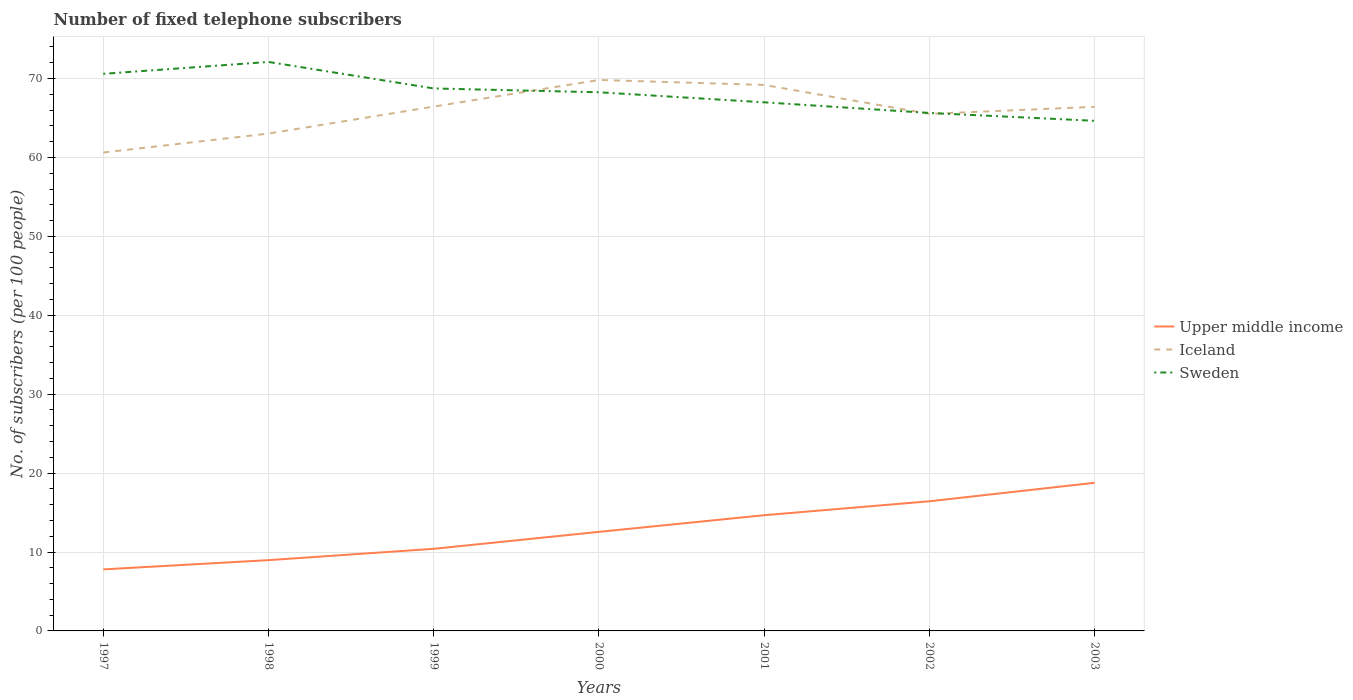Is the number of lines equal to the number of legend labels?
Offer a very short reply. Yes. Across all years, what is the maximum number of fixed telephone subscribers in Sweden?
Offer a terse response. 64.64. What is the total number of fixed telephone subscribers in Upper middle income in the graph?
Offer a terse response. -6.02. What is the difference between the highest and the second highest number of fixed telephone subscribers in Upper middle income?
Offer a terse response. 10.98. What is the difference between the highest and the lowest number of fixed telephone subscribers in Iceland?
Make the answer very short. 4. How many lines are there?
Provide a succinct answer. 3. Are the values on the major ticks of Y-axis written in scientific E-notation?
Ensure brevity in your answer.  No. Does the graph contain any zero values?
Offer a very short reply. No. Does the graph contain grids?
Make the answer very short. Yes. Where does the legend appear in the graph?
Offer a very short reply. Center right. How many legend labels are there?
Give a very brief answer. 3. What is the title of the graph?
Your answer should be compact. Number of fixed telephone subscribers. What is the label or title of the Y-axis?
Make the answer very short. No. of subscribers (per 100 people). What is the No. of subscribers (per 100 people) in Upper middle income in 1997?
Provide a short and direct response. 7.8. What is the No. of subscribers (per 100 people) of Iceland in 1997?
Offer a terse response. 60.63. What is the No. of subscribers (per 100 people) in Sweden in 1997?
Make the answer very short. 70.59. What is the No. of subscribers (per 100 people) of Upper middle income in 1998?
Provide a succinct answer. 8.97. What is the No. of subscribers (per 100 people) in Iceland in 1998?
Provide a short and direct response. 63.02. What is the No. of subscribers (per 100 people) in Sweden in 1998?
Offer a terse response. 72.1. What is the No. of subscribers (per 100 people) in Upper middle income in 1999?
Ensure brevity in your answer.  10.41. What is the No. of subscribers (per 100 people) of Iceland in 1999?
Keep it short and to the point. 66.45. What is the No. of subscribers (per 100 people) in Sweden in 1999?
Provide a short and direct response. 68.74. What is the No. of subscribers (per 100 people) of Upper middle income in 2000?
Give a very brief answer. 12.55. What is the No. of subscribers (per 100 people) in Iceland in 2000?
Your response must be concise. 69.82. What is the No. of subscribers (per 100 people) in Sweden in 2000?
Ensure brevity in your answer.  68.26. What is the No. of subscribers (per 100 people) of Upper middle income in 2001?
Your response must be concise. 14.66. What is the No. of subscribers (per 100 people) of Iceland in 2001?
Your answer should be compact. 69.19. What is the No. of subscribers (per 100 people) in Sweden in 2001?
Offer a very short reply. 66.99. What is the No. of subscribers (per 100 people) of Upper middle income in 2002?
Your answer should be compact. 16.43. What is the No. of subscribers (per 100 people) in Iceland in 2002?
Provide a short and direct response. 65.52. What is the No. of subscribers (per 100 people) in Sweden in 2002?
Ensure brevity in your answer.  65.64. What is the No. of subscribers (per 100 people) of Upper middle income in 2003?
Keep it short and to the point. 18.77. What is the No. of subscribers (per 100 people) in Iceland in 2003?
Your response must be concise. 66.41. What is the No. of subscribers (per 100 people) in Sweden in 2003?
Your answer should be compact. 64.64. Across all years, what is the maximum No. of subscribers (per 100 people) of Upper middle income?
Provide a short and direct response. 18.77. Across all years, what is the maximum No. of subscribers (per 100 people) in Iceland?
Provide a succinct answer. 69.82. Across all years, what is the maximum No. of subscribers (per 100 people) in Sweden?
Ensure brevity in your answer.  72.1. Across all years, what is the minimum No. of subscribers (per 100 people) of Upper middle income?
Offer a very short reply. 7.8. Across all years, what is the minimum No. of subscribers (per 100 people) in Iceland?
Provide a short and direct response. 60.63. Across all years, what is the minimum No. of subscribers (per 100 people) in Sweden?
Your response must be concise. 64.64. What is the total No. of subscribers (per 100 people) in Upper middle income in the graph?
Your response must be concise. 89.59. What is the total No. of subscribers (per 100 people) of Iceland in the graph?
Give a very brief answer. 461.04. What is the total No. of subscribers (per 100 people) in Sweden in the graph?
Make the answer very short. 476.96. What is the difference between the No. of subscribers (per 100 people) of Upper middle income in 1997 and that in 1998?
Offer a very short reply. -1.17. What is the difference between the No. of subscribers (per 100 people) of Iceland in 1997 and that in 1998?
Provide a short and direct response. -2.4. What is the difference between the No. of subscribers (per 100 people) of Sweden in 1997 and that in 1998?
Provide a short and direct response. -1.51. What is the difference between the No. of subscribers (per 100 people) of Upper middle income in 1997 and that in 1999?
Provide a succinct answer. -2.61. What is the difference between the No. of subscribers (per 100 people) in Iceland in 1997 and that in 1999?
Your answer should be very brief. -5.82. What is the difference between the No. of subscribers (per 100 people) in Sweden in 1997 and that in 1999?
Offer a very short reply. 1.85. What is the difference between the No. of subscribers (per 100 people) in Upper middle income in 1997 and that in 2000?
Offer a terse response. -4.76. What is the difference between the No. of subscribers (per 100 people) in Iceland in 1997 and that in 2000?
Give a very brief answer. -9.19. What is the difference between the No. of subscribers (per 100 people) of Sweden in 1997 and that in 2000?
Provide a short and direct response. 2.34. What is the difference between the No. of subscribers (per 100 people) in Upper middle income in 1997 and that in 2001?
Your response must be concise. -6.87. What is the difference between the No. of subscribers (per 100 people) in Iceland in 1997 and that in 2001?
Your response must be concise. -8.56. What is the difference between the No. of subscribers (per 100 people) of Sweden in 1997 and that in 2001?
Your answer should be very brief. 3.61. What is the difference between the No. of subscribers (per 100 people) in Upper middle income in 1997 and that in 2002?
Offer a terse response. -8.63. What is the difference between the No. of subscribers (per 100 people) in Iceland in 1997 and that in 2002?
Ensure brevity in your answer.  -4.89. What is the difference between the No. of subscribers (per 100 people) of Sweden in 1997 and that in 2002?
Provide a succinct answer. 4.96. What is the difference between the No. of subscribers (per 100 people) of Upper middle income in 1997 and that in 2003?
Provide a short and direct response. -10.98. What is the difference between the No. of subscribers (per 100 people) in Iceland in 1997 and that in 2003?
Provide a succinct answer. -5.79. What is the difference between the No. of subscribers (per 100 people) of Sweden in 1997 and that in 2003?
Give a very brief answer. 5.95. What is the difference between the No. of subscribers (per 100 people) of Upper middle income in 1998 and that in 1999?
Offer a very short reply. -1.44. What is the difference between the No. of subscribers (per 100 people) of Iceland in 1998 and that in 1999?
Your response must be concise. -3.42. What is the difference between the No. of subscribers (per 100 people) of Sweden in 1998 and that in 1999?
Your response must be concise. 3.36. What is the difference between the No. of subscribers (per 100 people) of Upper middle income in 1998 and that in 2000?
Your answer should be very brief. -3.58. What is the difference between the No. of subscribers (per 100 people) of Iceland in 1998 and that in 2000?
Your response must be concise. -6.79. What is the difference between the No. of subscribers (per 100 people) in Sweden in 1998 and that in 2000?
Offer a very short reply. 3.84. What is the difference between the No. of subscribers (per 100 people) of Upper middle income in 1998 and that in 2001?
Give a very brief answer. -5.69. What is the difference between the No. of subscribers (per 100 people) in Iceland in 1998 and that in 2001?
Provide a succinct answer. -6.16. What is the difference between the No. of subscribers (per 100 people) of Sweden in 1998 and that in 2001?
Offer a terse response. 5.12. What is the difference between the No. of subscribers (per 100 people) in Upper middle income in 1998 and that in 2002?
Provide a short and direct response. -7.46. What is the difference between the No. of subscribers (per 100 people) in Iceland in 1998 and that in 2002?
Your response must be concise. -2.5. What is the difference between the No. of subscribers (per 100 people) of Sweden in 1998 and that in 2002?
Your response must be concise. 6.46. What is the difference between the No. of subscribers (per 100 people) of Upper middle income in 1998 and that in 2003?
Offer a very short reply. -9.8. What is the difference between the No. of subscribers (per 100 people) in Iceland in 1998 and that in 2003?
Give a very brief answer. -3.39. What is the difference between the No. of subscribers (per 100 people) of Sweden in 1998 and that in 2003?
Your response must be concise. 7.46. What is the difference between the No. of subscribers (per 100 people) in Upper middle income in 1999 and that in 2000?
Keep it short and to the point. -2.15. What is the difference between the No. of subscribers (per 100 people) in Iceland in 1999 and that in 2000?
Offer a terse response. -3.37. What is the difference between the No. of subscribers (per 100 people) in Sweden in 1999 and that in 2000?
Offer a very short reply. 0.48. What is the difference between the No. of subscribers (per 100 people) of Upper middle income in 1999 and that in 2001?
Keep it short and to the point. -4.26. What is the difference between the No. of subscribers (per 100 people) in Iceland in 1999 and that in 2001?
Ensure brevity in your answer.  -2.74. What is the difference between the No. of subscribers (per 100 people) in Sweden in 1999 and that in 2001?
Your answer should be compact. 1.76. What is the difference between the No. of subscribers (per 100 people) in Upper middle income in 1999 and that in 2002?
Offer a terse response. -6.02. What is the difference between the No. of subscribers (per 100 people) in Iceland in 1999 and that in 2002?
Ensure brevity in your answer.  0.93. What is the difference between the No. of subscribers (per 100 people) of Sweden in 1999 and that in 2002?
Provide a succinct answer. 3.1. What is the difference between the No. of subscribers (per 100 people) in Upper middle income in 1999 and that in 2003?
Offer a very short reply. -8.37. What is the difference between the No. of subscribers (per 100 people) in Iceland in 1999 and that in 2003?
Your answer should be compact. 0.03. What is the difference between the No. of subscribers (per 100 people) in Sweden in 1999 and that in 2003?
Your answer should be very brief. 4.1. What is the difference between the No. of subscribers (per 100 people) of Upper middle income in 2000 and that in 2001?
Make the answer very short. -2.11. What is the difference between the No. of subscribers (per 100 people) of Iceland in 2000 and that in 2001?
Ensure brevity in your answer.  0.63. What is the difference between the No. of subscribers (per 100 people) in Sweden in 2000 and that in 2001?
Provide a succinct answer. 1.27. What is the difference between the No. of subscribers (per 100 people) in Upper middle income in 2000 and that in 2002?
Ensure brevity in your answer.  -3.88. What is the difference between the No. of subscribers (per 100 people) of Iceland in 2000 and that in 2002?
Provide a short and direct response. 4.3. What is the difference between the No. of subscribers (per 100 people) of Sweden in 2000 and that in 2002?
Keep it short and to the point. 2.62. What is the difference between the No. of subscribers (per 100 people) in Upper middle income in 2000 and that in 2003?
Make the answer very short. -6.22. What is the difference between the No. of subscribers (per 100 people) of Iceland in 2000 and that in 2003?
Keep it short and to the point. 3.4. What is the difference between the No. of subscribers (per 100 people) of Sweden in 2000 and that in 2003?
Your answer should be compact. 3.62. What is the difference between the No. of subscribers (per 100 people) in Upper middle income in 2001 and that in 2002?
Ensure brevity in your answer.  -1.77. What is the difference between the No. of subscribers (per 100 people) in Iceland in 2001 and that in 2002?
Offer a very short reply. 3.67. What is the difference between the No. of subscribers (per 100 people) of Sweden in 2001 and that in 2002?
Keep it short and to the point. 1.35. What is the difference between the No. of subscribers (per 100 people) of Upper middle income in 2001 and that in 2003?
Keep it short and to the point. -4.11. What is the difference between the No. of subscribers (per 100 people) in Iceland in 2001 and that in 2003?
Give a very brief answer. 2.77. What is the difference between the No. of subscribers (per 100 people) in Sweden in 2001 and that in 2003?
Offer a very short reply. 2.35. What is the difference between the No. of subscribers (per 100 people) of Upper middle income in 2002 and that in 2003?
Give a very brief answer. -2.34. What is the difference between the No. of subscribers (per 100 people) of Iceland in 2002 and that in 2003?
Your answer should be compact. -0.89. What is the difference between the No. of subscribers (per 100 people) in Sweden in 2002 and that in 2003?
Give a very brief answer. 1. What is the difference between the No. of subscribers (per 100 people) of Upper middle income in 1997 and the No. of subscribers (per 100 people) of Iceland in 1998?
Ensure brevity in your answer.  -55.23. What is the difference between the No. of subscribers (per 100 people) in Upper middle income in 1997 and the No. of subscribers (per 100 people) in Sweden in 1998?
Keep it short and to the point. -64.3. What is the difference between the No. of subscribers (per 100 people) in Iceland in 1997 and the No. of subscribers (per 100 people) in Sweden in 1998?
Offer a very short reply. -11.47. What is the difference between the No. of subscribers (per 100 people) of Upper middle income in 1997 and the No. of subscribers (per 100 people) of Iceland in 1999?
Keep it short and to the point. -58.65. What is the difference between the No. of subscribers (per 100 people) in Upper middle income in 1997 and the No. of subscribers (per 100 people) in Sweden in 1999?
Your response must be concise. -60.94. What is the difference between the No. of subscribers (per 100 people) of Iceland in 1997 and the No. of subscribers (per 100 people) of Sweden in 1999?
Make the answer very short. -8.11. What is the difference between the No. of subscribers (per 100 people) of Upper middle income in 1997 and the No. of subscribers (per 100 people) of Iceland in 2000?
Your answer should be very brief. -62.02. What is the difference between the No. of subscribers (per 100 people) of Upper middle income in 1997 and the No. of subscribers (per 100 people) of Sweden in 2000?
Ensure brevity in your answer.  -60.46. What is the difference between the No. of subscribers (per 100 people) of Iceland in 1997 and the No. of subscribers (per 100 people) of Sweden in 2000?
Ensure brevity in your answer.  -7.63. What is the difference between the No. of subscribers (per 100 people) in Upper middle income in 1997 and the No. of subscribers (per 100 people) in Iceland in 2001?
Provide a succinct answer. -61.39. What is the difference between the No. of subscribers (per 100 people) of Upper middle income in 1997 and the No. of subscribers (per 100 people) of Sweden in 2001?
Ensure brevity in your answer.  -59.19. What is the difference between the No. of subscribers (per 100 people) of Iceland in 1997 and the No. of subscribers (per 100 people) of Sweden in 2001?
Your answer should be compact. -6.36. What is the difference between the No. of subscribers (per 100 people) of Upper middle income in 1997 and the No. of subscribers (per 100 people) of Iceland in 2002?
Offer a terse response. -57.72. What is the difference between the No. of subscribers (per 100 people) in Upper middle income in 1997 and the No. of subscribers (per 100 people) in Sweden in 2002?
Offer a very short reply. -57.84. What is the difference between the No. of subscribers (per 100 people) of Iceland in 1997 and the No. of subscribers (per 100 people) of Sweden in 2002?
Offer a terse response. -5.01. What is the difference between the No. of subscribers (per 100 people) in Upper middle income in 1997 and the No. of subscribers (per 100 people) in Iceland in 2003?
Make the answer very short. -58.62. What is the difference between the No. of subscribers (per 100 people) in Upper middle income in 1997 and the No. of subscribers (per 100 people) in Sweden in 2003?
Your answer should be very brief. -56.84. What is the difference between the No. of subscribers (per 100 people) of Iceland in 1997 and the No. of subscribers (per 100 people) of Sweden in 2003?
Make the answer very short. -4.01. What is the difference between the No. of subscribers (per 100 people) of Upper middle income in 1998 and the No. of subscribers (per 100 people) of Iceland in 1999?
Your answer should be compact. -57.48. What is the difference between the No. of subscribers (per 100 people) of Upper middle income in 1998 and the No. of subscribers (per 100 people) of Sweden in 1999?
Give a very brief answer. -59.77. What is the difference between the No. of subscribers (per 100 people) of Iceland in 1998 and the No. of subscribers (per 100 people) of Sweden in 1999?
Offer a very short reply. -5.72. What is the difference between the No. of subscribers (per 100 people) in Upper middle income in 1998 and the No. of subscribers (per 100 people) in Iceland in 2000?
Ensure brevity in your answer.  -60.85. What is the difference between the No. of subscribers (per 100 people) in Upper middle income in 1998 and the No. of subscribers (per 100 people) in Sweden in 2000?
Ensure brevity in your answer.  -59.29. What is the difference between the No. of subscribers (per 100 people) in Iceland in 1998 and the No. of subscribers (per 100 people) in Sweden in 2000?
Provide a short and direct response. -5.23. What is the difference between the No. of subscribers (per 100 people) of Upper middle income in 1998 and the No. of subscribers (per 100 people) of Iceland in 2001?
Your answer should be compact. -60.22. What is the difference between the No. of subscribers (per 100 people) of Upper middle income in 1998 and the No. of subscribers (per 100 people) of Sweden in 2001?
Keep it short and to the point. -58.02. What is the difference between the No. of subscribers (per 100 people) in Iceland in 1998 and the No. of subscribers (per 100 people) in Sweden in 2001?
Your answer should be very brief. -3.96. What is the difference between the No. of subscribers (per 100 people) in Upper middle income in 1998 and the No. of subscribers (per 100 people) in Iceland in 2002?
Provide a succinct answer. -56.55. What is the difference between the No. of subscribers (per 100 people) in Upper middle income in 1998 and the No. of subscribers (per 100 people) in Sweden in 2002?
Offer a very short reply. -56.67. What is the difference between the No. of subscribers (per 100 people) in Iceland in 1998 and the No. of subscribers (per 100 people) in Sweden in 2002?
Ensure brevity in your answer.  -2.61. What is the difference between the No. of subscribers (per 100 people) in Upper middle income in 1998 and the No. of subscribers (per 100 people) in Iceland in 2003?
Give a very brief answer. -57.44. What is the difference between the No. of subscribers (per 100 people) of Upper middle income in 1998 and the No. of subscribers (per 100 people) of Sweden in 2003?
Keep it short and to the point. -55.67. What is the difference between the No. of subscribers (per 100 people) of Iceland in 1998 and the No. of subscribers (per 100 people) of Sweden in 2003?
Provide a short and direct response. -1.62. What is the difference between the No. of subscribers (per 100 people) of Upper middle income in 1999 and the No. of subscribers (per 100 people) of Iceland in 2000?
Your response must be concise. -59.41. What is the difference between the No. of subscribers (per 100 people) in Upper middle income in 1999 and the No. of subscribers (per 100 people) in Sweden in 2000?
Offer a very short reply. -57.85. What is the difference between the No. of subscribers (per 100 people) of Iceland in 1999 and the No. of subscribers (per 100 people) of Sweden in 2000?
Your answer should be very brief. -1.81. What is the difference between the No. of subscribers (per 100 people) in Upper middle income in 1999 and the No. of subscribers (per 100 people) in Iceland in 2001?
Your answer should be compact. -58.78. What is the difference between the No. of subscribers (per 100 people) in Upper middle income in 1999 and the No. of subscribers (per 100 people) in Sweden in 2001?
Ensure brevity in your answer.  -56.58. What is the difference between the No. of subscribers (per 100 people) in Iceland in 1999 and the No. of subscribers (per 100 people) in Sweden in 2001?
Make the answer very short. -0.54. What is the difference between the No. of subscribers (per 100 people) in Upper middle income in 1999 and the No. of subscribers (per 100 people) in Iceland in 2002?
Offer a terse response. -55.12. What is the difference between the No. of subscribers (per 100 people) in Upper middle income in 1999 and the No. of subscribers (per 100 people) in Sweden in 2002?
Make the answer very short. -55.23. What is the difference between the No. of subscribers (per 100 people) of Iceland in 1999 and the No. of subscribers (per 100 people) of Sweden in 2002?
Provide a short and direct response. 0.81. What is the difference between the No. of subscribers (per 100 people) in Upper middle income in 1999 and the No. of subscribers (per 100 people) in Iceland in 2003?
Offer a very short reply. -56.01. What is the difference between the No. of subscribers (per 100 people) in Upper middle income in 1999 and the No. of subscribers (per 100 people) in Sweden in 2003?
Your response must be concise. -54.24. What is the difference between the No. of subscribers (per 100 people) in Iceland in 1999 and the No. of subscribers (per 100 people) in Sweden in 2003?
Give a very brief answer. 1.81. What is the difference between the No. of subscribers (per 100 people) in Upper middle income in 2000 and the No. of subscribers (per 100 people) in Iceland in 2001?
Make the answer very short. -56.63. What is the difference between the No. of subscribers (per 100 people) of Upper middle income in 2000 and the No. of subscribers (per 100 people) of Sweden in 2001?
Make the answer very short. -54.43. What is the difference between the No. of subscribers (per 100 people) in Iceland in 2000 and the No. of subscribers (per 100 people) in Sweden in 2001?
Make the answer very short. 2.83. What is the difference between the No. of subscribers (per 100 people) of Upper middle income in 2000 and the No. of subscribers (per 100 people) of Iceland in 2002?
Your response must be concise. -52.97. What is the difference between the No. of subscribers (per 100 people) in Upper middle income in 2000 and the No. of subscribers (per 100 people) in Sweden in 2002?
Your answer should be very brief. -53.08. What is the difference between the No. of subscribers (per 100 people) in Iceland in 2000 and the No. of subscribers (per 100 people) in Sweden in 2002?
Offer a terse response. 4.18. What is the difference between the No. of subscribers (per 100 people) of Upper middle income in 2000 and the No. of subscribers (per 100 people) of Iceland in 2003?
Offer a very short reply. -53.86. What is the difference between the No. of subscribers (per 100 people) of Upper middle income in 2000 and the No. of subscribers (per 100 people) of Sweden in 2003?
Offer a very short reply. -52.09. What is the difference between the No. of subscribers (per 100 people) of Iceland in 2000 and the No. of subscribers (per 100 people) of Sweden in 2003?
Make the answer very short. 5.18. What is the difference between the No. of subscribers (per 100 people) in Upper middle income in 2001 and the No. of subscribers (per 100 people) in Iceland in 2002?
Give a very brief answer. -50.86. What is the difference between the No. of subscribers (per 100 people) in Upper middle income in 2001 and the No. of subscribers (per 100 people) in Sweden in 2002?
Keep it short and to the point. -50.97. What is the difference between the No. of subscribers (per 100 people) in Iceland in 2001 and the No. of subscribers (per 100 people) in Sweden in 2002?
Make the answer very short. 3.55. What is the difference between the No. of subscribers (per 100 people) in Upper middle income in 2001 and the No. of subscribers (per 100 people) in Iceland in 2003?
Your response must be concise. -51.75. What is the difference between the No. of subscribers (per 100 people) in Upper middle income in 2001 and the No. of subscribers (per 100 people) in Sweden in 2003?
Keep it short and to the point. -49.98. What is the difference between the No. of subscribers (per 100 people) in Iceland in 2001 and the No. of subscribers (per 100 people) in Sweden in 2003?
Provide a succinct answer. 4.55. What is the difference between the No. of subscribers (per 100 people) of Upper middle income in 2002 and the No. of subscribers (per 100 people) of Iceland in 2003?
Provide a short and direct response. -49.98. What is the difference between the No. of subscribers (per 100 people) of Upper middle income in 2002 and the No. of subscribers (per 100 people) of Sweden in 2003?
Ensure brevity in your answer.  -48.21. What is the difference between the No. of subscribers (per 100 people) in Iceland in 2002 and the No. of subscribers (per 100 people) in Sweden in 2003?
Provide a short and direct response. 0.88. What is the average No. of subscribers (per 100 people) of Upper middle income per year?
Your answer should be very brief. 12.8. What is the average No. of subscribers (per 100 people) of Iceland per year?
Your answer should be compact. 65.86. What is the average No. of subscribers (per 100 people) in Sweden per year?
Offer a very short reply. 68.14. In the year 1997, what is the difference between the No. of subscribers (per 100 people) of Upper middle income and No. of subscribers (per 100 people) of Iceland?
Make the answer very short. -52.83. In the year 1997, what is the difference between the No. of subscribers (per 100 people) in Upper middle income and No. of subscribers (per 100 people) in Sweden?
Keep it short and to the point. -62.8. In the year 1997, what is the difference between the No. of subscribers (per 100 people) in Iceland and No. of subscribers (per 100 people) in Sweden?
Provide a succinct answer. -9.97. In the year 1998, what is the difference between the No. of subscribers (per 100 people) of Upper middle income and No. of subscribers (per 100 people) of Iceland?
Provide a succinct answer. -54.05. In the year 1998, what is the difference between the No. of subscribers (per 100 people) of Upper middle income and No. of subscribers (per 100 people) of Sweden?
Offer a very short reply. -63.13. In the year 1998, what is the difference between the No. of subscribers (per 100 people) of Iceland and No. of subscribers (per 100 people) of Sweden?
Give a very brief answer. -9.08. In the year 1999, what is the difference between the No. of subscribers (per 100 people) in Upper middle income and No. of subscribers (per 100 people) in Iceland?
Your answer should be compact. -56.04. In the year 1999, what is the difference between the No. of subscribers (per 100 people) of Upper middle income and No. of subscribers (per 100 people) of Sweden?
Your answer should be compact. -58.34. In the year 1999, what is the difference between the No. of subscribers (per 100 people) in Iceland and No. of subscribers (per 100 people) in Sweden?
Make the answer very short. -2.29. In the year 2000, what is the difference between the No. of subscribers (per 100 people) of Upper middle income and No. of subscribers (per 100 people) of Iceland?
Offer a terse response. -57.26. In the year 2000, what is the difference between the No. of subscribers (per 100 people) in Upper middle income and No. of subscribers (per 100 people) in Sweden?
Provide a succinct answer. -55.7. In the year 2000, what is the difference between the No. of subscribers (per 100 people) in Iceland and No. of subscribers (per 100 people) in Sweden?
Give a very brief answer. 1.56. In the year 2001, what is the difference between the No. of subscribers (per 100 people) in Upper middle income and No. of subscribers (per 100 people) in Iceland?
Ensure brevity in your answer.  -54.52. In the year 2001, what is the difference between the No. of subscribers (per 100 people) in Upper middle income and No. of subscribers (per 100 people) in Sweden?
Your answer should be very brief. -52.32. In the year 2001, what is the difference between the No. of subscribers (per 100 people) of Iceland and No. of subscribers (per 100 people) of Sweden?
Provide a short and direct response. 2.2. In the year 2002, what is the difference between the No. of subscribers (per 100 people) of Upper middle income and No. of subscribers (per 100 people) of Iceland?
Offer a very short reply. -49.09. In the year 2002, what is the difference between the No. of subscribers (per 100 people) of Upper middle income and No. of subscribers (per 100 people) of Sweden?
Your answer should be compact. -49.21. In the year 2002, what is the difference between the No. of subscribers (per 100 people) in Iceland and No. of subscribers (per 100 people) in Sweden?
Offer a terse response. -0.12. In the year 2003, what is the difference between the No. of subscribers (per 100 people) in Upper middle income and No. of subscribers (per 100 people) in Iceland?
Offer a very short reply. -47.64. In the year 2003, what is the difference between the No. of subscribers (per 100 people) of Upper middle income and No. of subscribers (per 100 people) of Sweden?
Ensure brevity in your answer.  -45.87. In the year 2003, what is the difference between the No. of subscribers (per 100 people) in Iceland and No. of subscribers (per 100 people) in Sweden?
Provide a succinct answer. 1.77. What is the ratio of the No. of subscribers (per 100 people) of Upper middle income in 1997 to that in 1998?
Your answer should be compact. 0.87. What is the ratio of the No. of subscribers (per 100 people) of Iceland in 1997 to that in 1998?
Give a very brief answer. 0.96. What is the ratio of the No. of subscribers (per 100 people) in Sweden in 1997 to that in 1998?
Your answer should be very brief. 0.98. What is the ratio of the No. of subscribers (per 100 people) of Upper middle income in 1997 to that in 1999?
Provide a succinct answer. 0.75. What is the ratio of the No. of subscribers (per 100 people) of Iceland in 1997 to that in 1999?
Your answer should be very brief. 0.91. What is the ratio of the No. of subscribers (per 100 people) in Sweden in 1997 to that in 1999?
Offer a terse response. 1.03. What is the ratio of the No. of subscribers (per 100 people) in Upper middle income in 1997 to that in 2000?
Offer a terse response. 0.62. What is the ratio of the No. of subscribers (per 100 people) of Iceland in 1997 to that in 2000?
Make the answer very short. 0.87. What is the ratio of the No. of subscribers (per 100 people) in Sweden in 1997 to that in 2000?
Make the answer very short. 1.03. What is the ratio of the No. of subscribers (per 100 people) of Upper middle income in 1997 to that in 2001?
Your response must be concise. 0.53. What is the ratio of the No. of subscribers (per 100 people) in Iceland in 1997 to that in 2001?
Keep it short and to the point. 0.88. What is the ratio of the No. of subscribers (per 100 people) in Sweden in 1997 to that in 2001?
Ensure brevity in your answer.  1.05. What is the ratio of the No. of subscribers (per 100 people) in Upper middle income in 1997 to that in 2002?
Provide a short and direct response. 0.47. What is the ratio of the No. of subscribers (per 100 people) in Iceland in 1997 to that in 2002?
Ensure brevity in your answer.  0.93. What is the ratio of the No. of subscribers (per 100 people) in Sweden in 1997 to that in 2002?
Keep it short and to the point. 1.08. What is the ratio of the No. of subscribers (per 100 people) of Upper middle income in 1997 to that in 2003?
Your answer should be compact. 0.42. What is the ratio of the No. of subscribers (per 100 people) of Iceland in 1997 to that in 2003?
Offer a terse response. 0.91. What is the ratio of the No. of subscribers (per 100 people) in Sweden in 1997 to that in 2003?
Give a very brief answer. 1.09. What is the ratio of the No. of subscribers (per 100 people) of Upper middle income in 1998 to that in 1999?
Make the answer very short. 0.86. What is the ratio of the No. of subscribers (per 100 people) in Iceland in 1998 to that in 1999?
Provide a succinct answer. 0.95. What is the ratio of the No. of subscribers (per 100 people) in Sweden in 1998 to that in 1999?
Give a very brief answer. 1.05. What is the ratio of the No. of subscribers (per 100 people) in Upper middle income in 1998 to that in 2000?
Your answer should be compact. 0.71. What is the ratio of the No. of subscribers (per 100 people) of Iceland in 1998 to that in 2000?
Provide a succinct answer. 0.9. What is the ratio of the No. of subscribers (per 100 people) of Sweden in 1998 to that in 2000?
Offer a terse response. 1.06. What is the ratio of the No. of subscribers (per 100 people) of Upper middle income in 1998 to that in 2001?
Provide a short and direct response. 0.61. What is the ratio of the No. of subscribers (per 100 people) of Iceland in 1998 to that in 2001?
Your response must be concise. 0.91. What is the ratio of the No. of subscribers (per 100 people) in Sweden in 1998 to that in 2001?
Provide a short and direct response. 1.08. What is the ratio of the No. of subscribers (per 100 people) in Upper middle income in 1998 to that in 2002?
Offer a very short reply. 0.55. What is the ratio of the No. of subscribers (per 100 people) in Iceland in 1998 to that in 2002?
Ensure brevity in your answer.  0.96. What is the ratio of the No. of subscribers (per 100 people) in Sweden in 1998 to that in 2002?
Provide a short and direct response. 1.1. What is the ratio of the No. of subscribers (per 100 people) in Upper middle income in 1998 to that in 2003?
Your answer should be very brief. 0.48. What is the ratio of the No. of subscribers (per 100 people) of Iceland in 1998 to that in 2003?
Offer a terse response. 0.95. What is the ratio of the No. of subscribers (per 100 people) in Sweden in 1998 to that in 2003?
Keep it short and to the point. 1.12. What is the ratio of the No. of subscribers (per 100 people) in Upper middle income in 1999 to that in 2000?
Provide a succinct answer. 0.83. What is the ratio of the No. of subscribers (per 100 people) in Iceland in 1999 to that in 2000?
Your answer should be very brief. 0.95. What is the ratio of the No. of subscribers (per 100 people) of Sweden in 1999 to that in 2000?
Offer a terse response. 1.01. What is the ratio of the No. of subscribers (per 100 people) of Upper middle income in 1999 to that in 2001?
Provide a succinct answer. 0.71. What is the ratio of the No. of subscribers (per 100 people) of Iceland in 1999 to that in 2001?
Provide a short and direct response. 0.96. What is the ratio of the No. of subscribers (per 100 people) of Sweden in 1999 to that in 2001?
Provide a short and direct response. 1.03. What is the ratio of the No. of subscribers (per 100 people) of Upper middle income in 1999 to that in 2002?
Ensure brevity in your answer.  0.63. What is the ratio of the No. of subscribers (per 100 people) in Iceland in 1999 to that in 2002?
Provide a succinct answer. 1.01. What is the ratio of the No. of subscribers (per 100 people) in Sweden in 1999 to that in 2002?
Ensure brevity in your answer.  1.05. What is the ratio of the No. of subscribers (per 100 people) in Upper middle income in 1999 to that in 2003?
Your answer should be compact. 0.55. What is the ratio of the No. of subscribers (per 100 people) of Iceland in 1999 to that in 2003?
Your response must be concise. 1. What is the ratio of the No. of subscribers (per 100 people) in Sweden in 1999 to that in 2003?
Make the answer very short. 1.06. What is the ratio of the No. of subscribers (per 100 people) of Upper middle income in 2000 to that in 2001?
Give a very brief answer. 0.86. What is the ratio of the No. of subscribers (per 100 people) of Iceland in 2000 to that in 2001?
Keep it short and to the point. 1.01. What is the ratio of the No. of subscribers (per 100 people) in Upper middle income in 2000 to that in 2002?
Keep it short and to the point. 0.76. What is the ratio of the No. of subscribers (per 100 people) in Iceland in 2000 to that in 2002?
Make the answer very short. 1.07. What is the ratio of the No. of subscribers (per 100 people) in Sweden in 2000 to that in 2002?
Give a very brief answer. 1.04. What is the ratio of the No. of subscribers (per 100 people) in Upper middle income in 2000 to that in 2003?
Provide a succinct answer. 0.67. What is the ratio of the No. of subscribers (per 100 people) of Iceland in 2000 to that in 2003?
Your answer should be compact. 1.05. What is the ratio of the No. of subscribers (per 100 people) of Sweden in 2000 to that in 2003?
Your response must be concise. 1.06. What is the ratio of the No. of subscribers (per 100 people) in Upper middle income in 2001 to that in 2002?
Your answer should be very brief. 0.89. What is the ratio of the No. of subscribers (per 100 people) in Iceland in 2001 to that in 2002?
Make the answer very short. 1.06. What is the ratio of the No. of subscribers (per 100 people) of Sweden in 2001 to that in 2002?
Provide a short and direct response. 1.02. What is the ratio of the No. of subscribers (per 100 people) of Upper middle income in 2001 to that in 2003?
Your answer should be compact. 0.78. What is the ratio of the No. of subscribers (per 100 people) of Iceland in 2001 to that in 2003?
Offer a very short reply. 1.04. What is the ratio of the No. of subscribers (per 100 people) of Sweden in 2001 to that in 2003?
Ensure brevity in your answer.  1.04. What is the ratio of the No. of subscribers (per 100 people) in Upper middle income in 2002 to that in 2003?
Provide a short and direct response. 0.88. What is the ratio of the No. of subscribers (per 100 people) in Iceland in 2002 to that in 2003?
Your answer should be very brief. 0.99. What is the ratio of the No. of subscribers (per 100 people) in Sweden in 2002 to that in 2003?
Your answer should be compact. 1.02. What is the difference between the highest and the second highest No. of subscribers (per 100 people) in Upper middle income?
Make the answer very short. 2.34. What is the difference between the highest and the second highest No. of subscribers (per 100 people) of Iceland?
Your response must be concise. 0.63. What is the difference between the highest and the second highest No. of subscribers (per 100 people) in Sweden?
Your response must be concise. 1.51. What is the difference between the highest and the lowest No. of subscribers (per 100 people) of Upper middle income?
Offer a terse response. 10.98. What is the difference between the highest and the lowest No. of subscribers (per 100 people) in Iceland?
Ensure brevity in your answer.  9.19. What is the difference between the highest and the lowest No. of subscribers (per 100 people) in Sweden?
Offer a terse response. 7.46. 